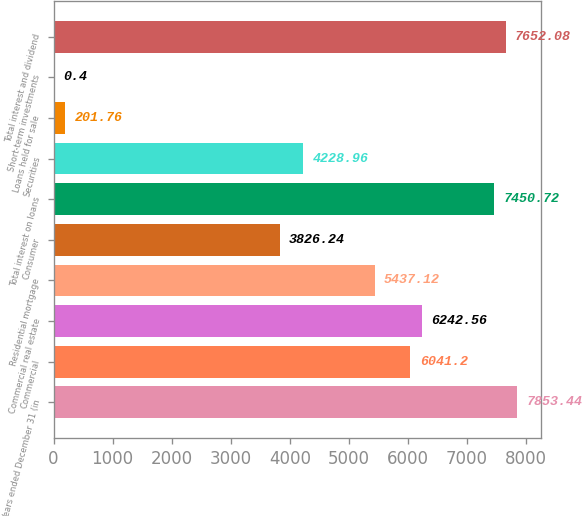Convert chart. <chart><loc_0><loc_0><loc_500><loc_500><bar_chart><fcel>Years ended December 31 (in<fcel>Commercial<fcel>Commercial real estate<fcel>Residential mortgage<fcel>Consumer<fcel>Total interest on loans<fcel>Securities<fcel>Loans held for sale<fcel>Short-term investments<fcel>Total interest and dividend<nl><fcel>7853.44<fcel>6041.2<fcel>6242.56<fcel>5437.12<fcel>3826.24<fcel>7450.72<fcel>4228.96<fcel>201.76<fcel>0.4<fcel>7652.08<nl></chart> 